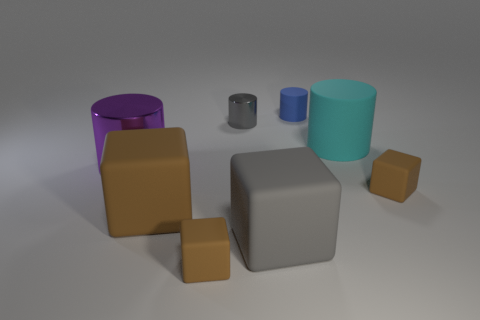Subtract all brown cylinders. How many brown cubes are left? 3 Add 1 small purple shiny blocks. How many objects exist? 9 Add 6 purple metal objects. How many purple metal objects are left? 7 Add 6 cyan metal blocks. How many cyan metal blocks exist? 6 Subtract 0 yellow spheres. How many objects are left? 8 Subtract all tiny green things. Subtract all small blue rubber cylinders. How many objects are left? 7 